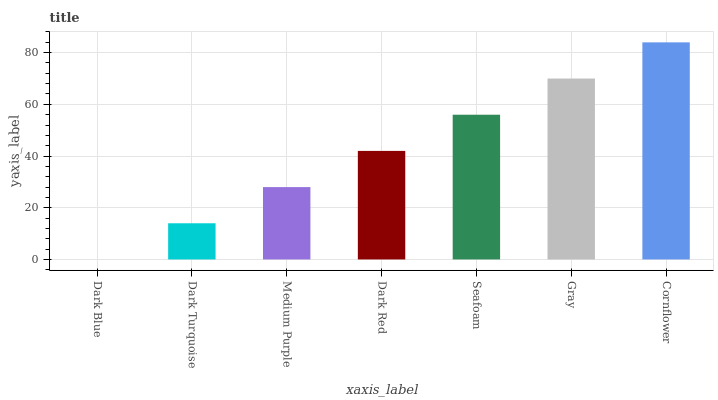Is Dark Blue the minimum?
Answer yes or no. Yes. Is Cornflower the maximum?
Answer yes or no. Yes. Is Dark Turquoise the minimum?
Answer yes or no. No. Is Dark Turquoise the maximum?
Answer yes or no. No. Is Dark Turquoise greater than Dark Blue?
Answer yes or no. Yes. Is Dark Blue less than Dark Turquoise?
Answer yes or no. Yes. Is Dark Blue greater than Dark Turquoise?
Answer yes or no. No. Is Dark Turquoise less than Dark Blue?
Answer yes or no. No. Is Dark Red the high median?
Answer yes or no. Yes. Is Dark Red the low median?
Answer yes or no. Yes. Is Dark Blue the high median?
Answer yes or no. No. Is Seafoam the low median?
Answer yes or no. No. 